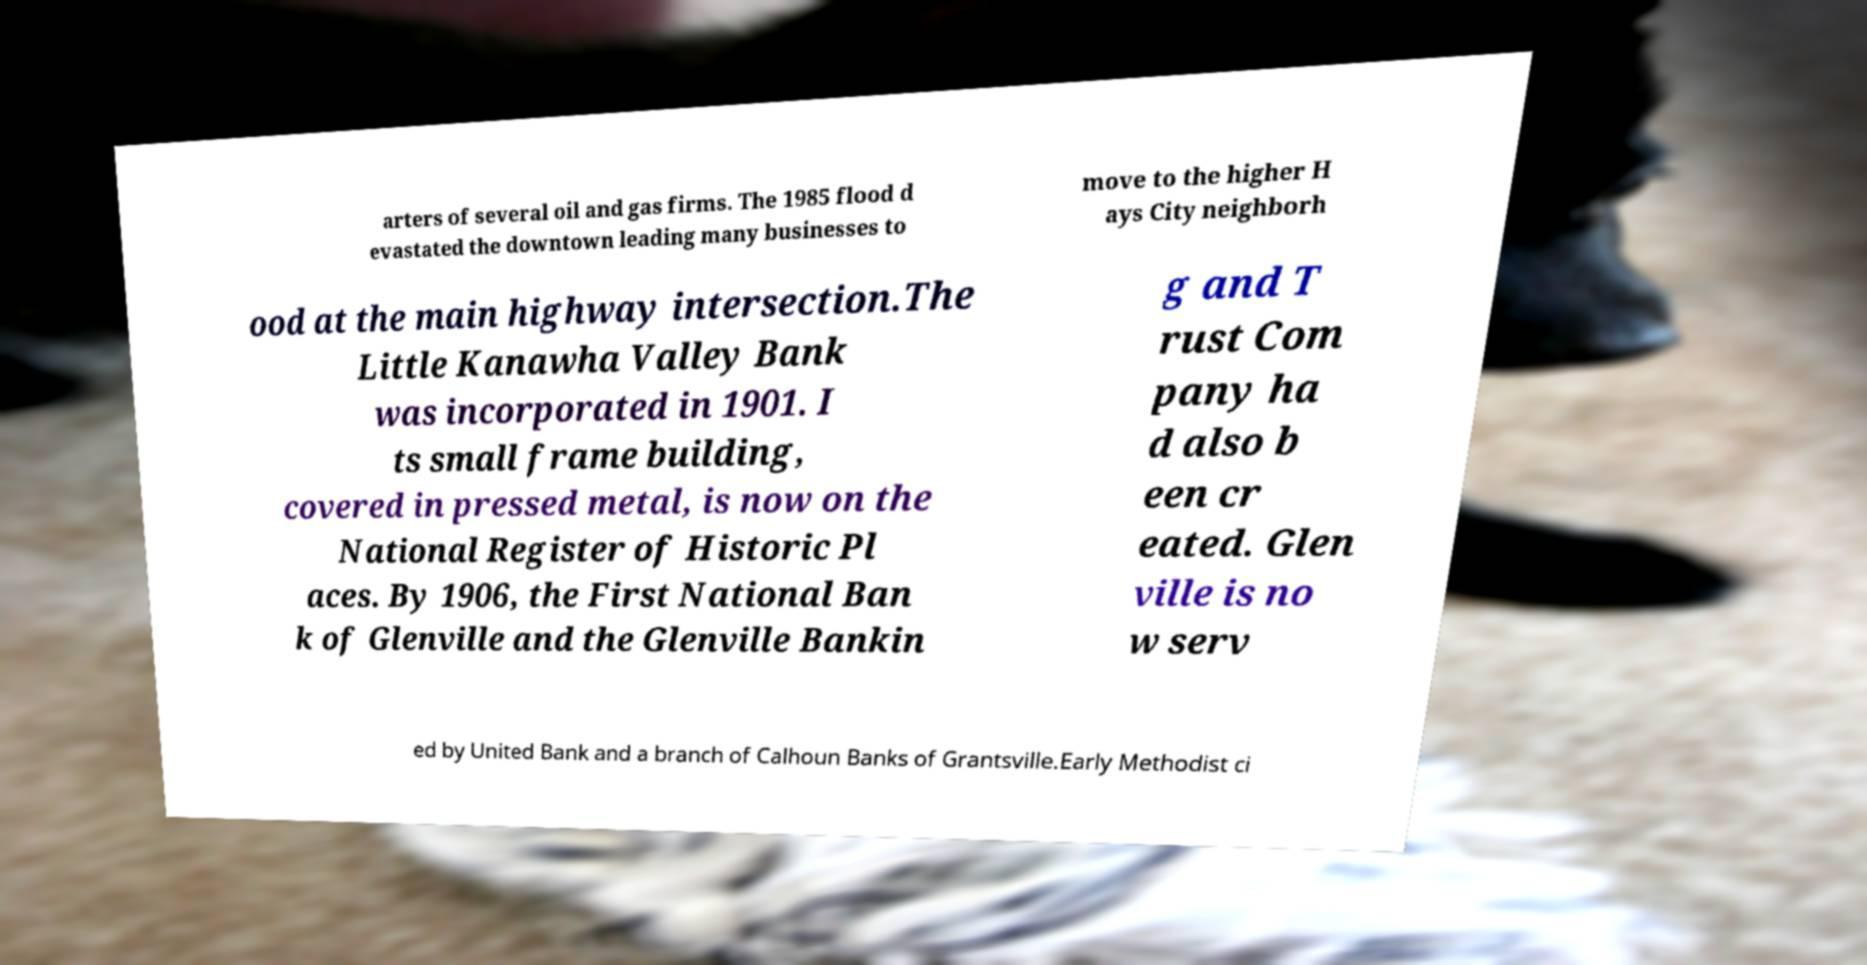Can you accurately transcribe the text from the provided image for me? arters of several oil and gas firms. The 1985 flood d evastated the downtown leading many businesses to move to the higher H ays City neighborh ood at the main highway intersection.The Little Kanawha Valley Bank was incorporated in 1901. I ts small frame building, covered in pressed metal, is now on the National Register of Historic Pl aces. By 1906, the First National Ban k of Glenville and the Glenville Bankin g and T rust Com pany ha d also b een cr eated. Glen ville is no w serv ed by United Bank and a branch of Calhoun Banks of Grantsville.Early Methodist ci 